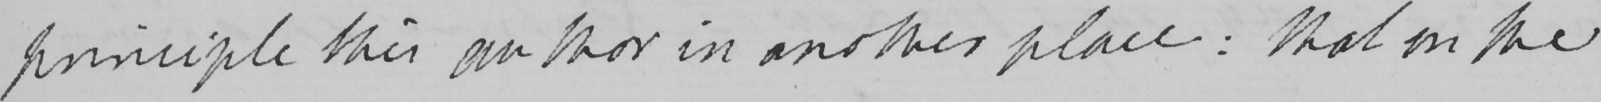Transcribe the text shown in this historical manuscript line. principle this author in another place :  that on the 